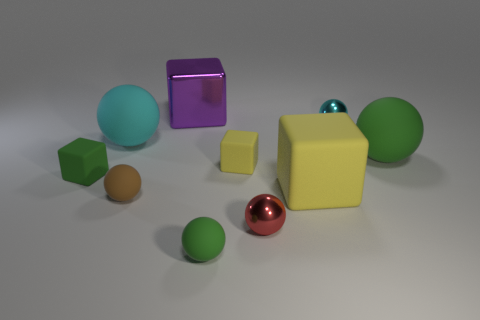How many objects have the same color as the big rubber cube?
Your response must be concise. 1. There is a large matte object that is the same shape as the purple metal thing; what is its color?
Provide a short and direct response. Yellow. There is a green matte ball that is in front of the small yellow object; what number of purple metallic blocks are in front of it?
Provide a short and direct response. 0. What number of spheres are either green objects or small yellow rubber objects?
Your answer should be very brief. 2. Are any tiny red things visible?
Your response must be concise. Yes. There is a red thing that is the same shape as the brown object; what size is it?
Provide a short and direct response. Small. There is a tiny thing that is behind the large thing that is to the right of the small cyan metal ball; what shape is it?
Ensure brevity in your answer.  Sphere. What number of cyan objects are either small metal balls or small blocks?
Keep it short and to the point. 1. The large shiny object is what color?
Make the answer very short. Purple. Do the red shiny object and the cyan shiny ball have the same size?
Make the answer very short. Yes. 